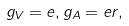Convert formula to latex. <formula><loc_0><loc_0><loc_500><loc_500>g _ { V } = e , g _ { A } = e r ,</formula> 